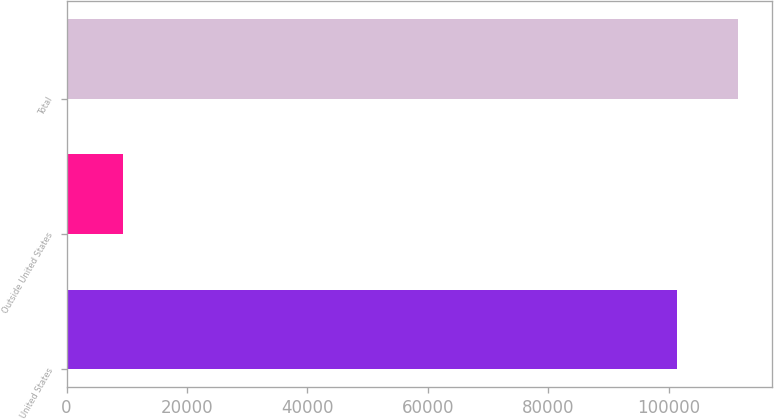Convert chart. <chart><loc_0><loc_0><loc_500><loc_500><bar_chart><fcel>United States<fcel>Outside United States<fcel>Total<nl><fcel>101454<fcel>9429<fcel>111599<nl></chart> 